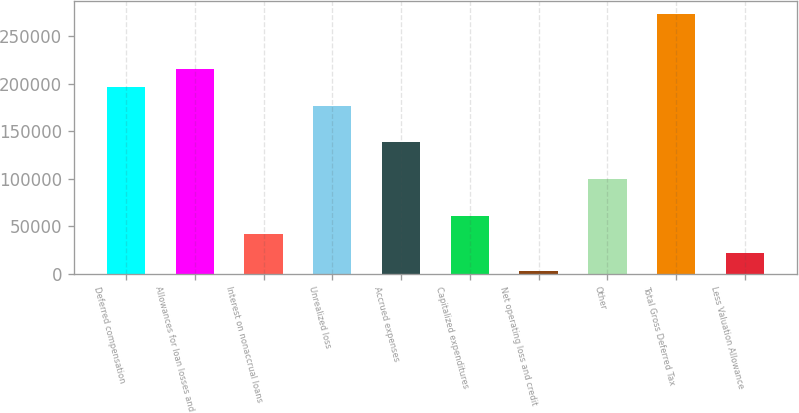Convert chart. <chart><loc_0><loc_0><loc_500><loc_500><bar_chart><fcel>Deferred compensation<fcel>Allowances for loan losses and<fcel>Interest on nonaccrual loans<fcel>Unrealized loss<fcel>Accrued expenses<fcel>Capitalized expenditures<fcel>Net operating loss and credit<fcel>Other<fcel>Total Gross Deferred Tax<fcel>Less Valuation Allowance<nl><fcel>196214<fcel>215527<fcel>41707.6<fcel>176901<fcel>138274<fcel>61020.9<fcel>3081<fcel>99647.5<fcel>273467<fcel>22394.3<nl></chart> 